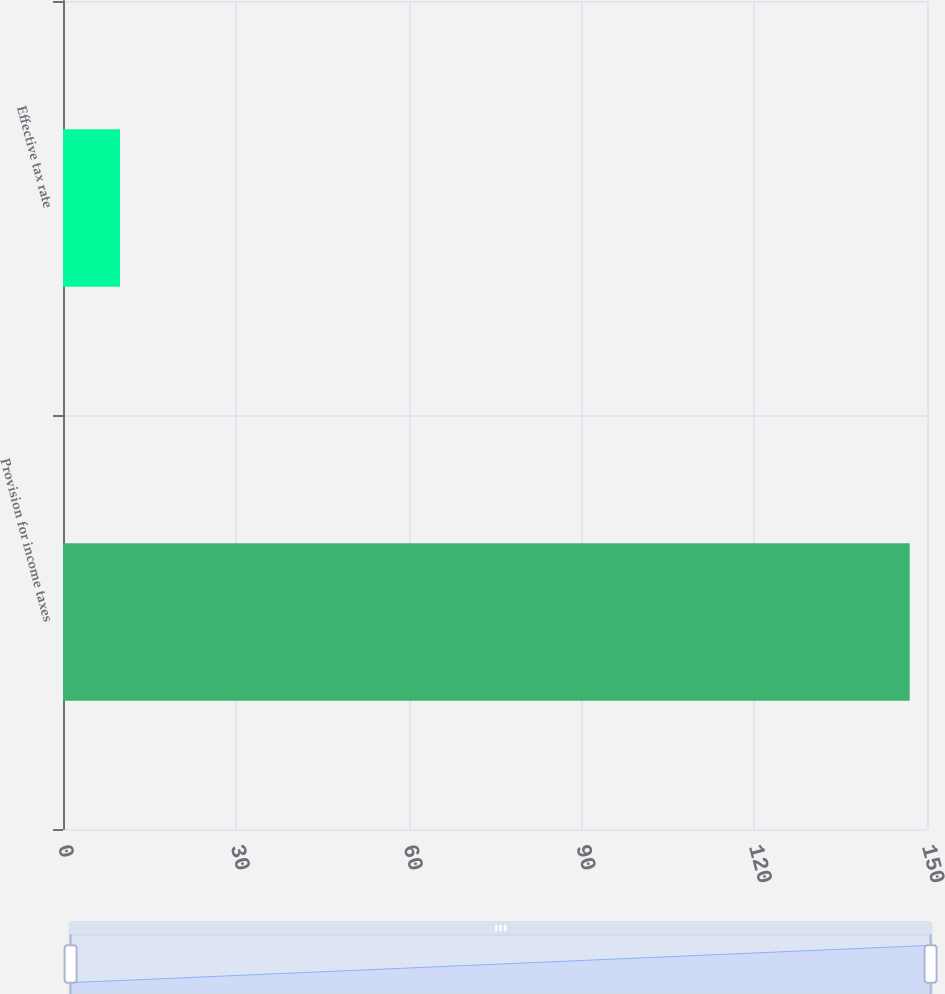<chart> <loc_0><loc_0><loc_500><loc_500><bar_chart><fcel>Provision for income taxes<fcel>Effective tax rate<nl><fcel>147<fcel>9.9<nl></chart> 